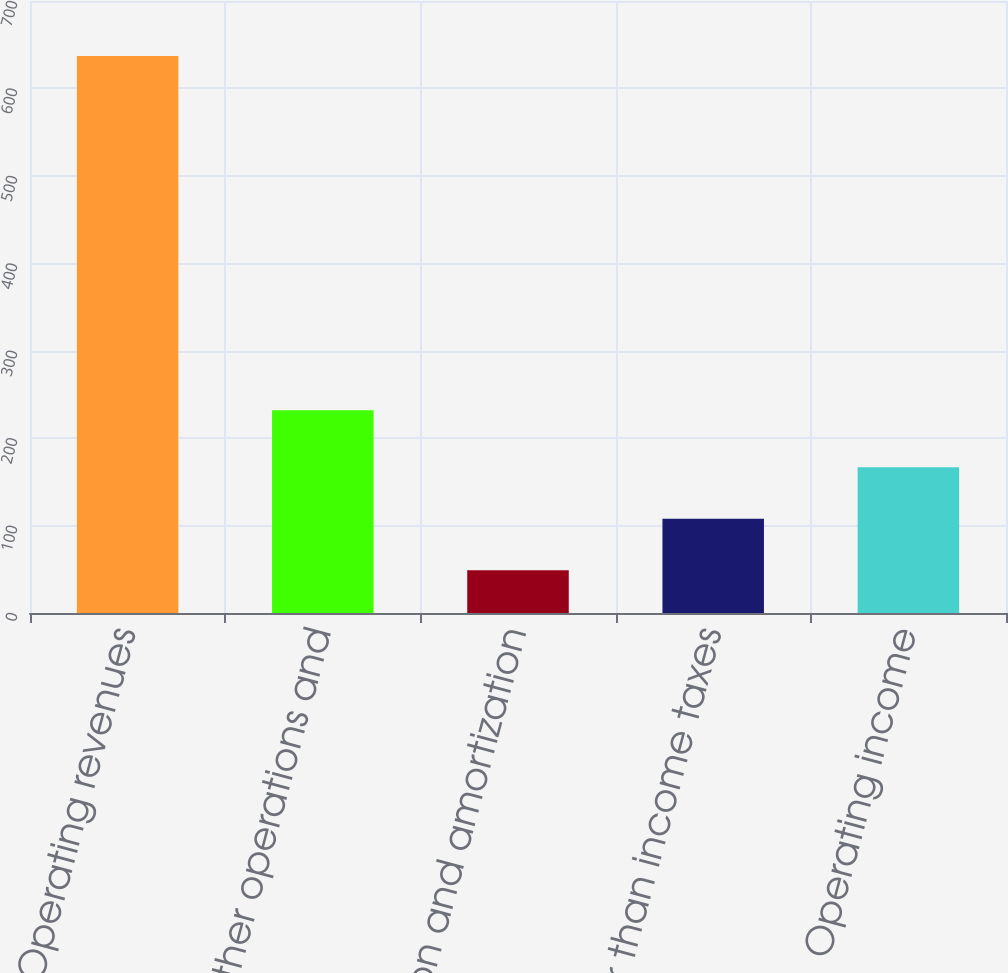Convert chart. <chart><loc_0><loc_0><loc_500><loc_500><bar_chart><fcel>Operating revenues<fcel>Other operations and<fcel>Depreciation and amortization<fcel>Taxes other than income taxes<fcel>Operating income<nl><fcel>637<fcel>232<fcel>49<fcel>107.8<fcel>166.6<nl></chart> 